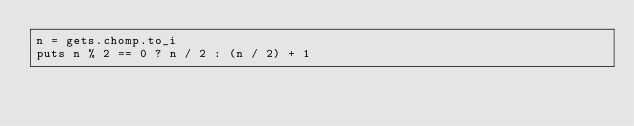Convert code to text. <code><loc_0><loc_0><loc_500><loc_500><_Ruby_>n = gets.chomp.to_i
puts n % 2 == 0 ? n / 2 : (n / 2) + 1</code> 